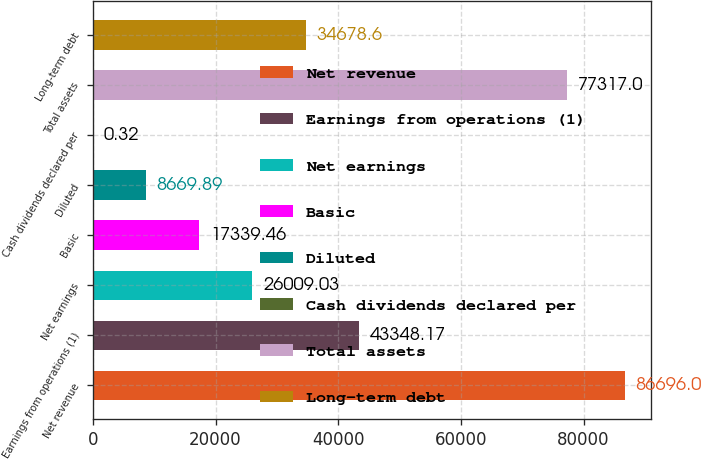Convert chart to OTSL. <chart><loc_0><loc_0><loc_500><loc_500><bar_chart><fcel>Net revenue<fcel>Earnings from operations (1)<fcel>Net earnings<fcel>Basic<fcel>Diluted<fcel>Cash dividends declared per<fcel>Total assets<fcel>Long-term debt<nl><fcel>86696<fcel>43348.2<fcel>26009<fcel>17339.5<fcel>8669.89<fcel>0.32<fcel>77317<fcel>34678.6<nl></chart> 